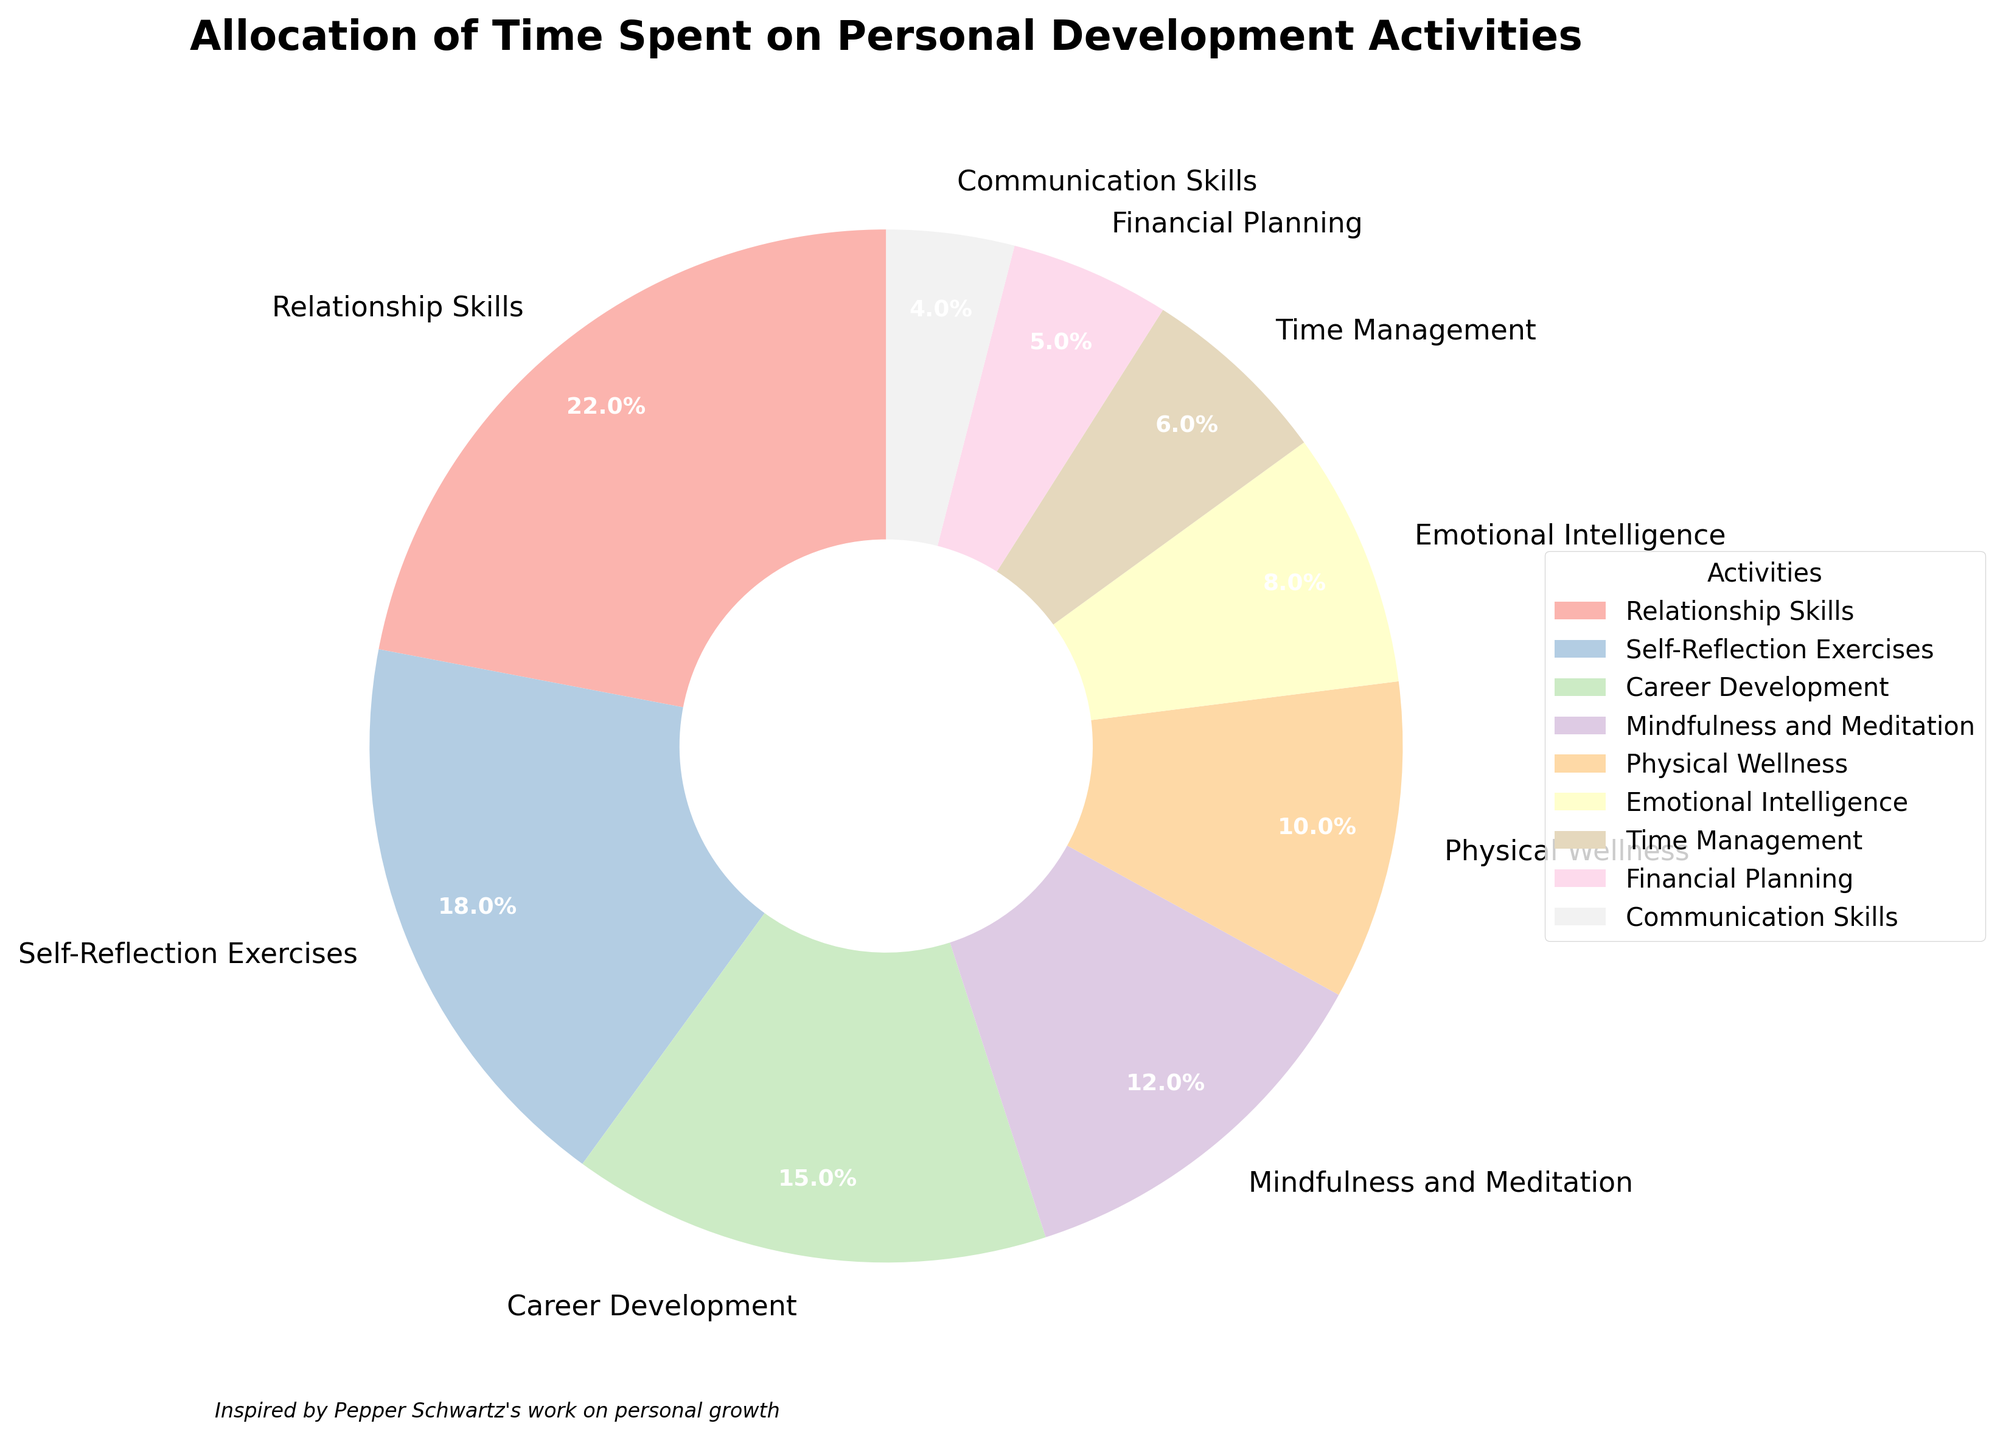Which activity do coaching clients spend the most time on? The segment labeled with the highest percentage represents the activity on which clients spend the most time. In this case, that is "Relationship Skills" with 22%.
Answer: Relationship Skills What is the total percentage of time spent on activities related to emotional and mental well-being (Emotional Intelligence and Mindfulness and Meditation)? The sum of the percentages for "Emotional Intelligence" (8%) and "Mindfulness and Meditation" (12%) gives the total percentage. 8% + 12% = 20%.
Answer: 20% How does the time spent on Career Development compare to that spent on Financial Planning? Compare the percentages for "Career Development" (15%) and "Financial Planning" (5%). 15% is greater than 5%.
Answer: Career Development is greater What percentage of time is spent on activities combining Physical Wellness and Time Management? The sum of the percentages for "Physical Wellness" (10%) and "Time Management" (6%) gives the total percentage. 10% + 6% = 16%.
Answer: 16% Which activity is allocated the least amount of time, and what is the percentage? The segment with the lowest percentage represents the activity allocated the least time, which is "Communication Skills" with 4%.
Answer: Communication Skills, 4% How much more time is spent on Self-Reflection Exercises than on Financial Planning? Subtract the percentage of "Financial Planning" (5%) from "Self-Reflection Exercises" (18%): 18% - 5% = 13%.
Answer: 13% If time spent on Mindfulness and Meditation were increased by 3%, what would the new percentage be? Add 3% to the current percentage for "Mindfulness and Meditation" (12%): 12% + 3% = 15%.
Answer: 15% Combine the time spent on activities related to skills (Time Management, Communication Skills, and Relationship Skills). What is the total percentage? Sum the percentages: "Time Management" (6%) + "Communication Skills" (4%) + "Relationship Skills" (22%): 6% + 4% + 22% = 32%.
Answer: 32% Which takes up a larger percentage of time: Emotional Intelligence or Physical Wellness? Compare the percentages: "Emotional Intelligence" (8%) and "Physical Wellness" (10%). 10% is greater than 8%.
Answer: Physical Wellness is greater What color represents Self-Reflection Exercises in the pie chart? Self-Reflection Exercises is represented by one of the colors in the legend and the corresponding segment in the pie chart. Based on pastel colors, it is visually the second segment from the top-left in the legend.
Answer: A pastel color (most likely pastel teal or a similar shade) 